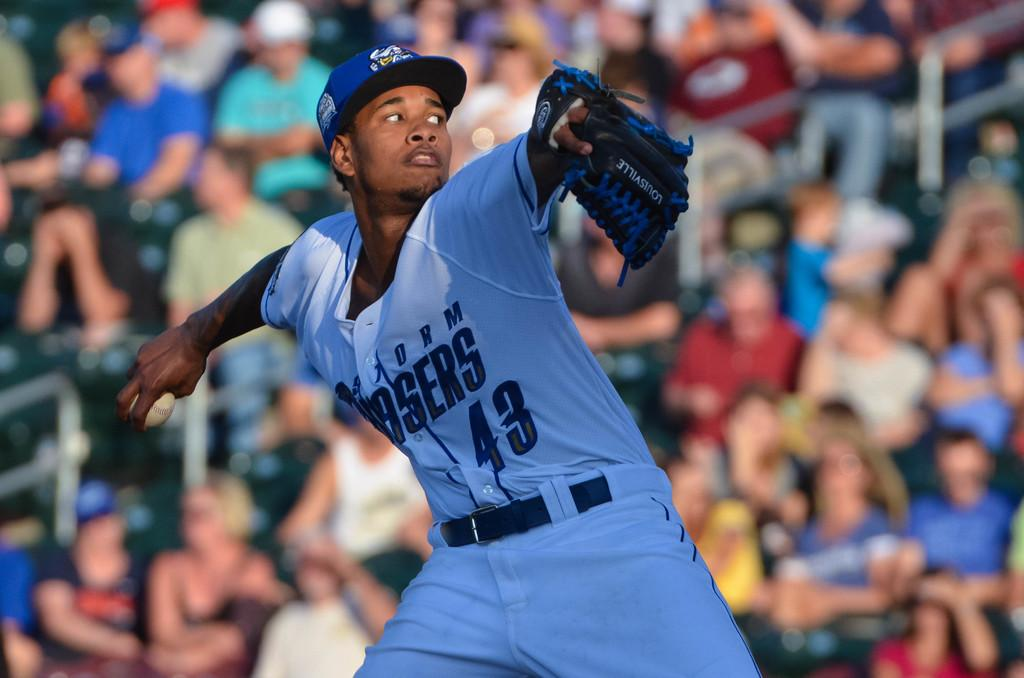<image>
Provide a brief description of the given image. a baseball player that is wearing the number 43 